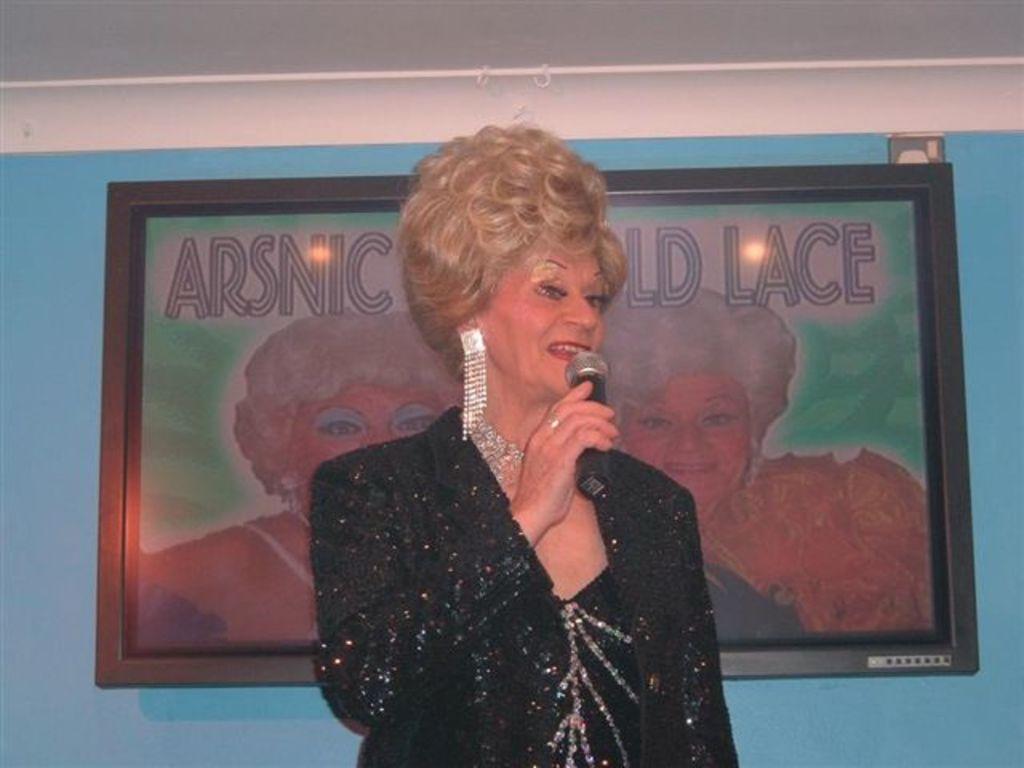Describe this image in one or two sentences. In this image we can see a lady speaking into a microphone. There is a photo frame on the wall. There is a blue colored wall in the image. 